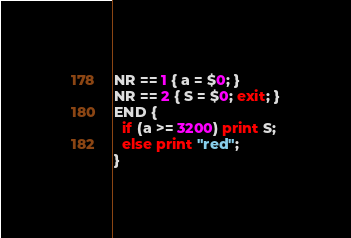<code> <loc_0><loc_0><loc_500><loc_500><_Awk_>NR == 1 { a = $0; }
NR == 2 { S = $0; exit; }
END {
  if (a >= 3200) print S;
  else print "red";
}</code> 